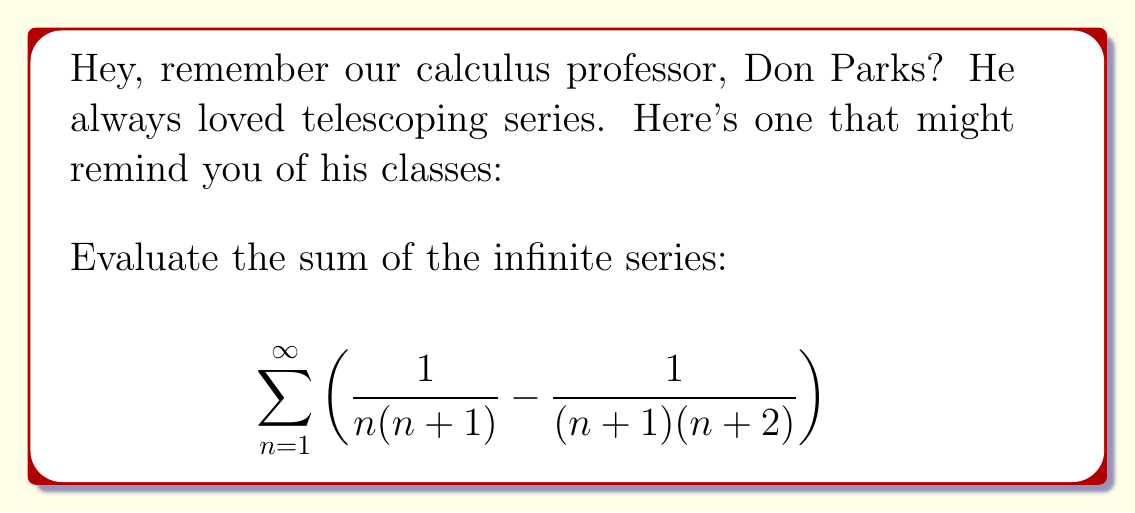Can you solve this math problem? Let's approach this step-by-step:

1) First, let's recognize the telescoping nature of this series. Each term can be split into two fractions:

   $$\sum_{n=1}^{\infty} \left(\frac{1}{n(n+1)} - \frac{1}{(n+1)(n+2)}\right)$$

2) We can rewrite each fraction using partial fraction decomposition:

   $$\sum_{n=1}^{\infty} \left[\left(\frac{1}{n} - \frac{1}{n+1}\right) - \left(\frac{1}{n+1} - \frac{1}{n+2}\right)\right]$$

3) Now, let's look at the partial sums. For any finite N:

   $$S_N = \sum_{n=1}^{N} \left[\left(\frac{1}{n} - \frac{1}{n+1}\right) - \left(\frac{1}{n+1} - \frac{1}{n+2}\right)\right]$$

4) Notice how terms cancel out within the sum:

   $$S_N = \left(\frac{1}{1} - \frac{1}{2}\right) + \left(\frac{1}{2} - \frac{1}{3}\right) + ... + \left(\frac{1}{N} - \frac{1}{N+1}\right) - \left[\left(\frac{1}{2} - \frac{1}{3}\right) + ... + \left(\frac{1}{N+1} - \frac{1}{N+2}\right)\right]$$

5) After cancellation, we're left with:

   $$S_N = \frac{1}{1} - \frac{1}{N+1} - \left(\frac{1}{N+1} - \frac{1}{N+2}\right)$$

6) Simplify:

   $$S_N = 1 - \frac{1}{N+1} - \frac{1}{N+1} + \frac{1}{N+2} = 1 - \frac{2}{N+1} + \frac{1}{N+2}$$

7) As N approaches infinity, both $\frac{2}{N+1}$ and $\frac{1}{N+2}$ approach 0.

8) Therefore, the limit of the partial sums as N approaches infinity is:

   $$\lim_{N \to \infty} S_N = 1 - 0 + 0 = 1$$

Thus, the sum of the infinite series is 1.
Answer: $1$ 